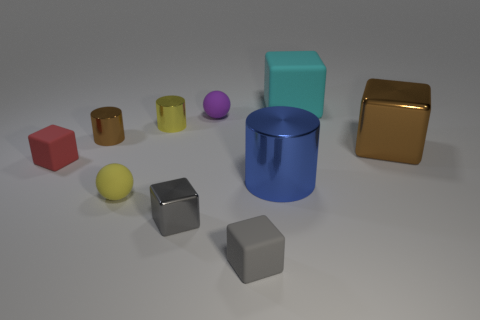How many objects are there in total and can you describe their colors and shapes? In the image, there is a total of 10 objects consisting of a variety of shapes and colors. Specifically, there are 3 cylinders, 3 spheres, and 4 cubes. The cylinders come in blue, tiny brown and metallic gold, while the cubes are seen in grey, red, brown and shiny gold, and the spheres are purple, yellow, and pink. 